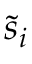Convert formula to latex. <formula><loc_0><loc_0><loc_500><loc_500>{ \tilde { s } } _ { i }</formula> 